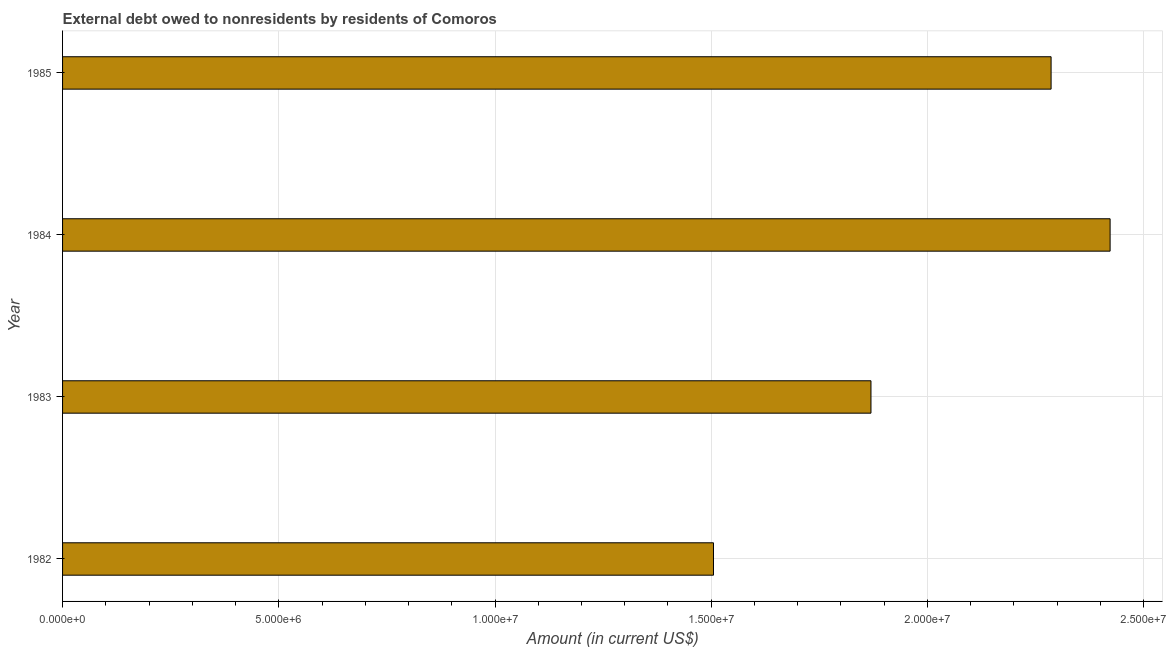Does the graph contain grids?
Keep it short and to the point. Yes. What is the title of the graph?
Ensure brevity in your answer.  External debt owed to nonresidents by residents of Comoros. What is the debt in 1982?
Make the answer very short. 1.51e+07. Across all years, what is the maximum debt?
Give a very brief answer. 2.42e+07. Across all years, what is the minimum debt?
Your response must be concise. 1.51e+07. In which year was the debt minimum?
Keep it short and to the point. 1982. What is the sum of the debt?
Your answer should be very brief. 8.08e+07. What is the difference between the debt in 1983 and 1985?
Your answer should be very brief. -4.16e+06. What is the average debt per year?
Ensure brevity in your answer.  2.02e+07. What is the median debt?
Provide a short and direct response. 2.08e+07. In how many years, is the debt greater than 4000000 US$?
Make the answer very short. 4. What is the ratio of the debt in 1983 to that in 1984?
Offer a terse response. 0.77. What is the difference between the highest and the second highest debt?
Ensure brevity in your answer.  1.36e+06. What is the difference between the highest and the lowest debt?
Ensure brevity in your answer.  9.17e+06. In how many years, is the debt greater than the average debt taken over all years?
Ensure brevity in your answer.  2. How many bars are there?
Keep it short and to the point. 4. Are all the bars in the graph horizontal?
Your answer should be very brief. Yes. Are the values on the major ticks of X-axis written in scientific E-notation?
Offer a very short reply. Yes. What is the Amount (in current US$) in 1982?
Ensure brevity in your answer.  1.51e+07. What is the Amount (in current US$) in 1983?
Your response must be concise. 1.87e+07. What is the Amount (in current US$) of 1984?
Keep it short and to the point. 2.42e+07. What is the Amount (in current US$) of 1985?
Ensure brevity in your answer.  2.29e+07. What is the difference between the Amount (in current US$) in 1982 and 1983?
Make the answer very short. -3.64e+06. What is the difference between the Amount (in current US$) in 1982 and 1984?
Keep it short and to the point. -9.17e+06. What is the difference between the Amount (in current US$) in 1982 and 1985?
Offer a terse response. -7.81e+06. What is the difference between the Amount (in current US$) in 1983 and 1984?
Your answer should be compact. -5.53e+06. What is the difference between the Amount (in current US$) in 1983 and 1985?
Your answer should be compact. -4.16e+06. What is the difference between the Amount (in current US$) in 1984 and 1985?
Offer a terse response. 1.36e+06. What is the ratio of the Amount (in current US$) in 1982 to that in 1983?
Offer a very short reply. 0.81. What is the ratio of the Amount (in current US$) in 1982 to that in 1984?
Offer a very short reply. 0.62. What is the ratio of the Amount (in current US$) in 1982 to that in 1985?
Offer a terse response. 0.66. What is the ratio of the Amount (in current US$) in 1983 to that in 1984?
Offer a terse response. 0.77. What is the ratio of the Amount (in current US$) in 1983 to that in 1985?
Offer a terse response. 0.82. What is the ratio of the Amount (in current US$) in 1984 to that in 1985?
Offer a very short reply. 1.06. 